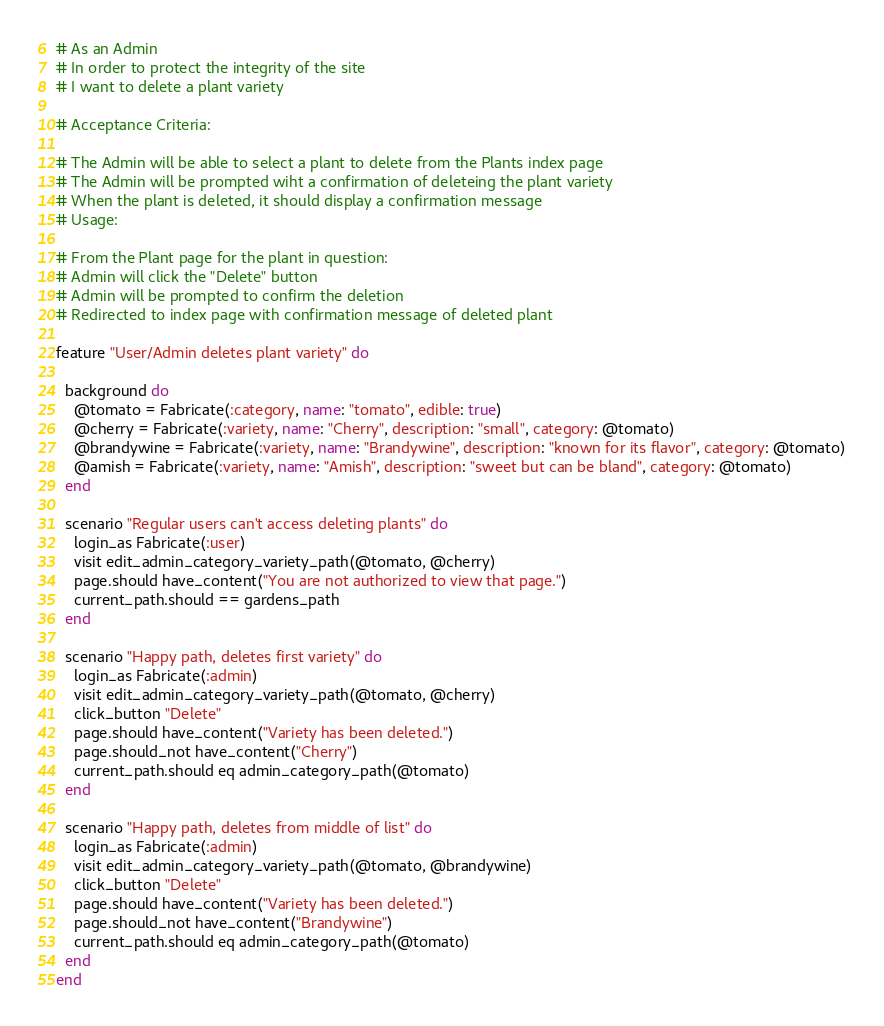<code> <loc_0><loc_0><loc_500><loc_500><_Ruby_># As an Admin
# In order to protect the integrity of the site
# I want to delete a plant variety

# Acceptance Criteria:

# The Admin will be able to select a plant to delete from the Plants index page
# The Admin will be prompted wiht a confirmation of deleteing the plant variety
# When the plant is deleted, it should display a confirmation message
# Usage:

# From the Plant page for the plant in question:
# Admin will click the "Delete" button
# Admin will be prompted to confirm the deletion
# Redirected to index page with confirmation message of deleted plant

feature "User/Admin deletes plant variety" do

  background do
    @tomato = Fabricate(:category, name: "tomato", edible: true)
    @cherry = Fabricate(:variety, name: "Cherry", description: "small", category: @tomato)
    @brandywine = Fabricate(:variety, name: "Brandywine", description: "known for its flavor", category: @tomato)
    @amish = Fabricate(:variety, name: "Amish", description: "sweet but can be bland", category: @tomato)
  end

  scenario "Regular users can't access deleting plants" do
    login_as Fabricate(:user)
    visit edit_admin_category_variety_path(@tomato, @cherry)
    page.should have_content("You are not authorized to view that page.")
    current_path.should == gardens_path
  end

  scenario "Happy path, deletes first variety" do
    login_as Fabricate(:admin)
    visit edit_admin_category_variety_path(@tomato, @cherry)
    click_button "Delete"
    page.should have_content("Variety has been deleted.")
    page.should_not have_content("Cherry")
    current_path.should eq admin_category_path(@tomato)
  end

  scenario "Happy path, deletes from middle of list" do
    login_as Fabricate(:admin)
    visit edit_admin_category_variety_path(@tomato, @brandywine)
    click_button "Delete"
    page.should have_content("Variety has been deleted.")
    page.should_not have_content("Brandywine")
    current_path.should eq admin_category_path(@tomato)
  end
end
</code> 